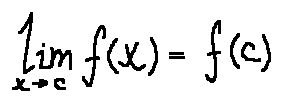Convert formula to latex. <formula><loc_0><loc_0><loc_500><loc_500>\lim \lim i t s _ { x \rightarrow c } f ( x ) = f ( c )</formula> 